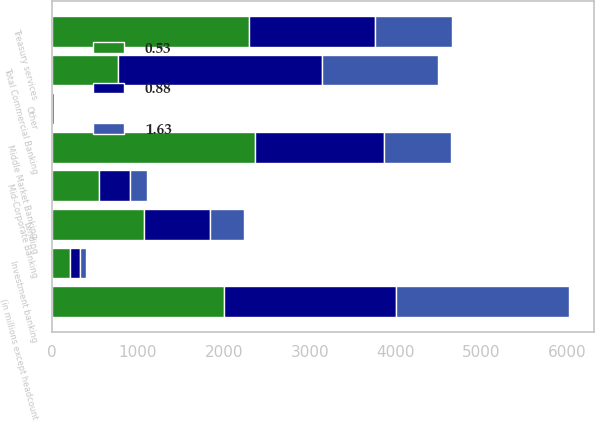Convert chart to OTSL. <chart><loc_0><loc_0><loc_500><loc_500><stacked_bar_chart><ecel><fcel>(in millions except headcount<fcel>Lending<fcel>Treasury services<fcel>Investment banking<fcel>Other<fcel>Total Commercial Banking<fcel>Middle Market Banking<fcel>Mid-Corporate Banking<nl><fcel>0.53<fcel>2005<fcel>1076<fcel>2299<fcel>213<fcel>8<fcel>772<fcel>2369<fcel>548<nl><fcel>0.88<fcel>2004<fcel>764<fcel>1467<fcel>120<fcel>23<fcel>2374<fcel>1499<fcel>367<nl><fcel>1.63<fcel>2003<fcel>396<fcel>896<fcel>66<fcel>6<fcel>1352<fcel>772<fcel>194<nl></chart> 